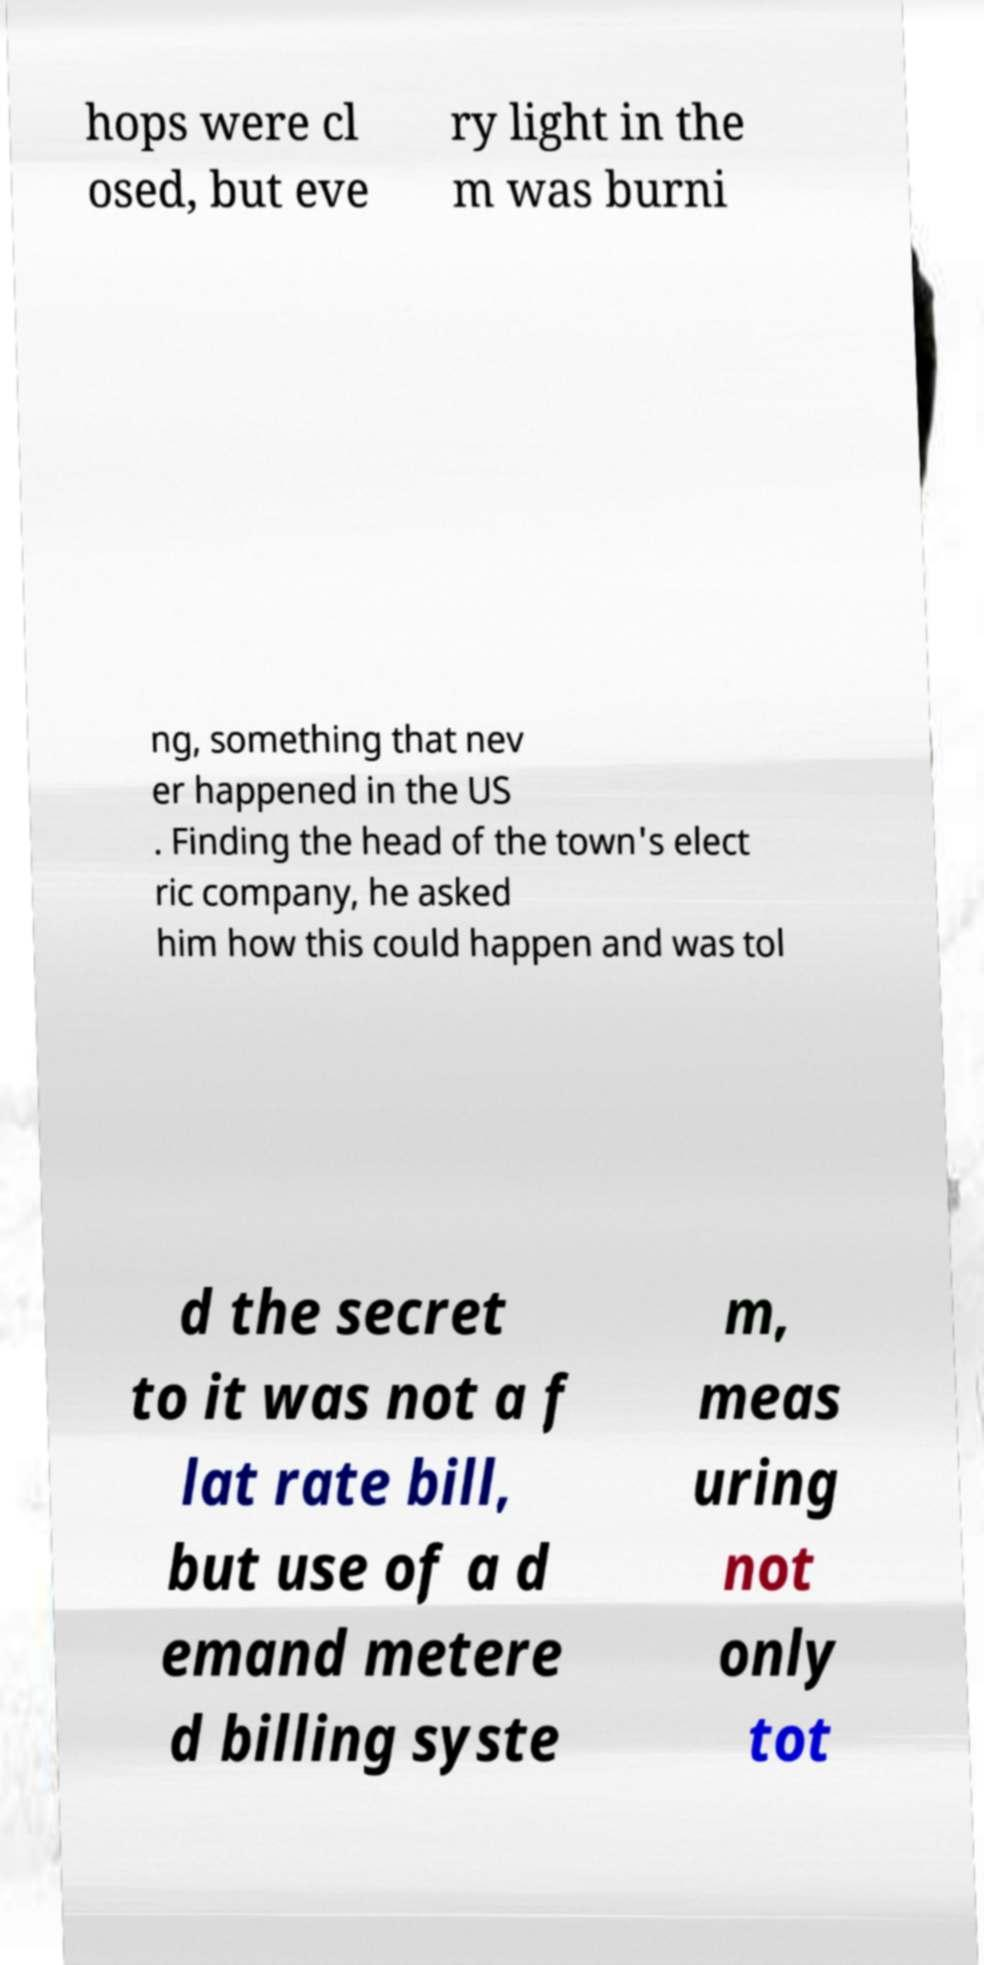There's text embedded in this image that I need extracted. Can you transcribe it verbatim? hops were cl osed, but eve ry light in the m was burni ng, something that nev er happened in the US . Finding the head of the town's elect ric company, he asked him how this could happen and was tol d the secret to it was not a f lat rate bill, but use of a d emand metere d billing syste m, meas uring not only tot 